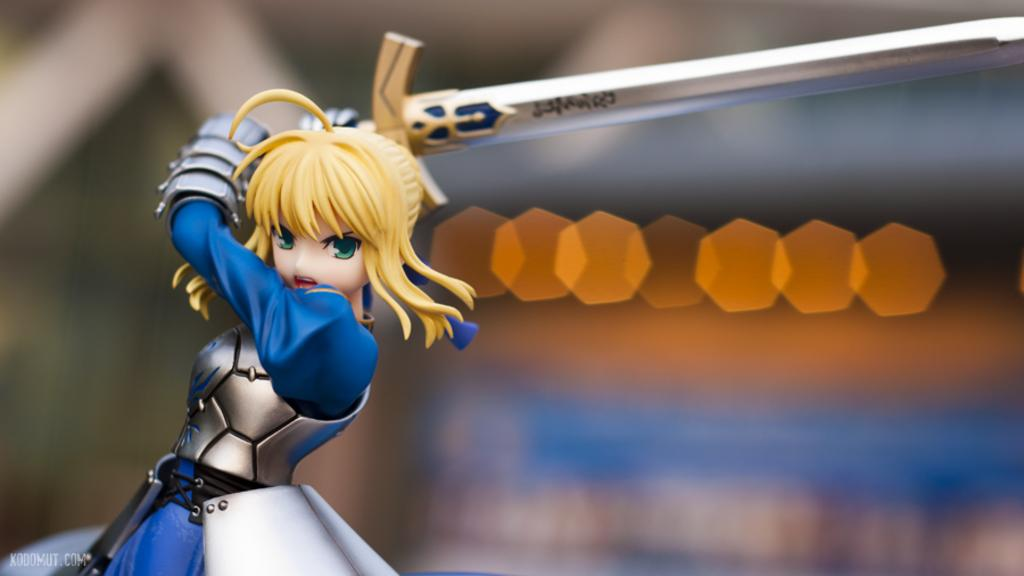What type of image is being described? The image is animated. Can you describe the main character in the image? There is a girl in the image. What is the girl holding in her hand? The girl is holding a sword in her hand. Is there any text present in the image? Yes, there is text at the bottom of the image. How would you describe the background of the image? The background of the image is blurred. What type of tools does the carpenter use in the image? There is no carpenter present in the image, so it is not possible to answer that question. 